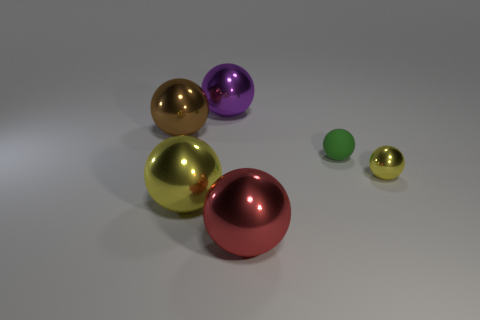There is a metallic ball that is on the left side of the yellow metallic thing that is in front of the small metal ball; what color is it?
Keep it short and to the point. Brown. What number of other objects are there of the same material as the large yellow sphere?
Provide a short and direct response. 4. Is the number of rubber spheres that are to the right of the red sphere the same as the number of big blue matte blocks?
Provide a short and direct response. No. There is a small object that is in front of the small object that is left of the yellow metallic ball that is to the right of the small green matte ball; what is its material?
Keep it short and to the point. Metal. The metal ball behind the brown metallic ball is what color?
Your answer should be very brief. Purple. Are there any other things that have the same shape as the large purple metallic thing?
Offer a terse response. Yes. There is a yellow shiny sphere that is left of the purple metallic thing behind the big brown sphere; what size is it?
Give a very brief answer. Large. Is the number of large purple balls behind the big purple sphere the same as the number of yellow metal objects that are right of the large red thing?
Offer a terse response. No. Is there anything else that is the same size as the purple sphere?
Provide a succinct answer. Yes. What color is the tiny thing that is the same material as the large red object?
Make the answer very short. Yellow. 